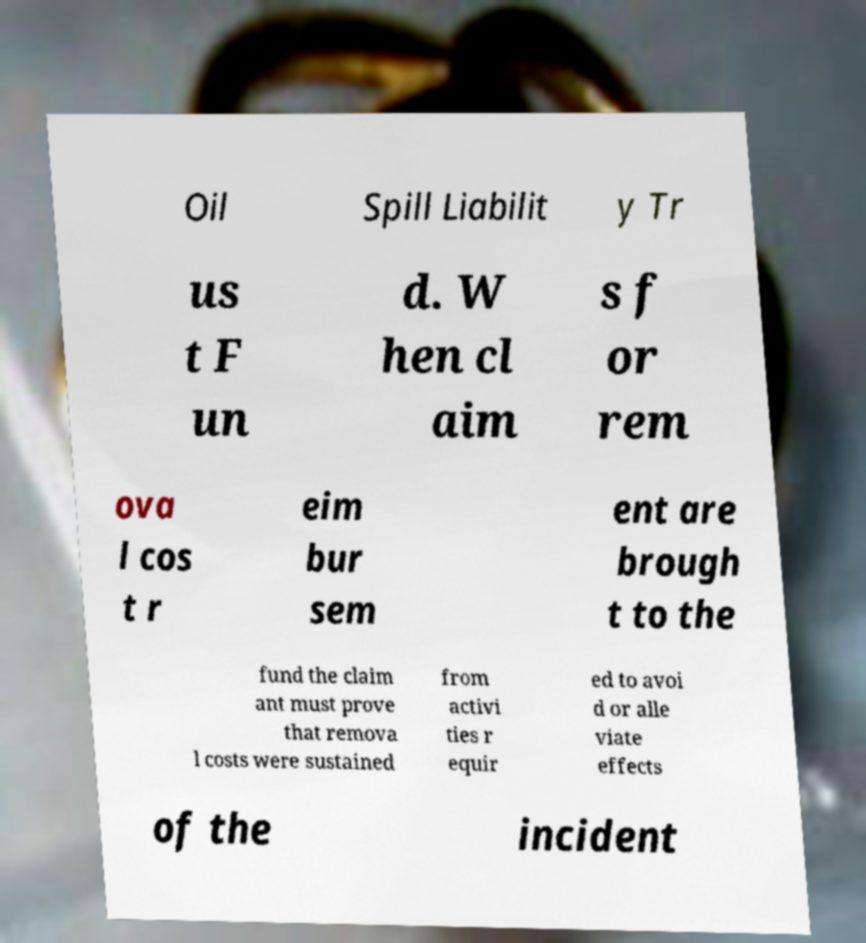Can you accurately transcribe the text from the provided image for me? Oil Spill Liabilit y Tr us t F un d. W hen cl aim s f or rem ova l cos t r eim bur sem ent are brough t to the fund the claim ant must prove that remova l costs were sustained from activi ties r equir ed to avoi d or alle viate effects of the incident 